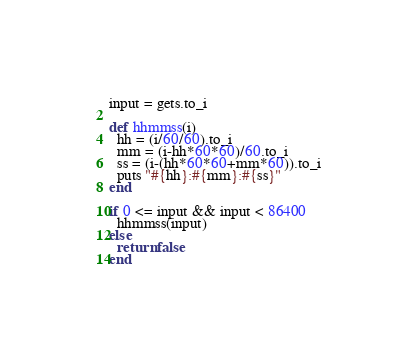Convert code to text. <code><loc_0><loc_0><loc_500><loc_500><_Ruby_>input = gets.to_i

def hhmmss(i)
  hh = (i/60/60).to_i
  mm = (i-hh*60*60)/60.to_i
  ss = (i-(hh*60*60+mm*60)).to_i
  puts "#{hh}:#{mm}:#{ss}"
end

if 0 <= input && input < 86400 
  hhmmss(input)
else
  return false
end

</code> 